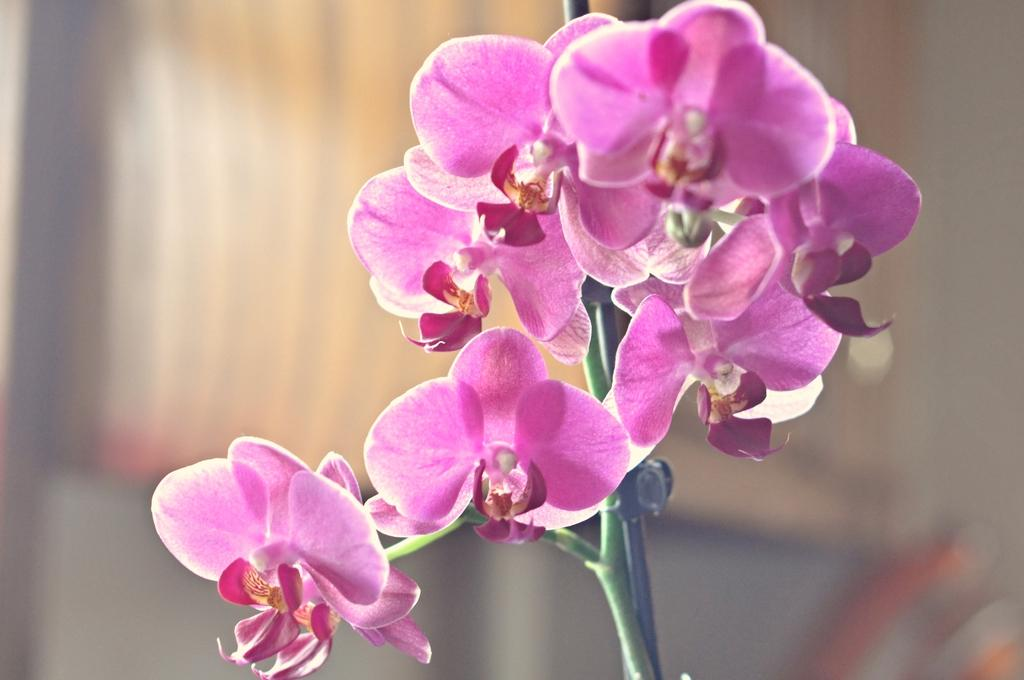What is present in the image? There are flowers in the image. Where are the flowers located? The flowers are on a plant. Can you describe the background of the image? The background of the image is blurry. Is there a river flowing through the cellar in the image? There is no river or cellar present in the image; it features flowers on a plant with a blurry background. 